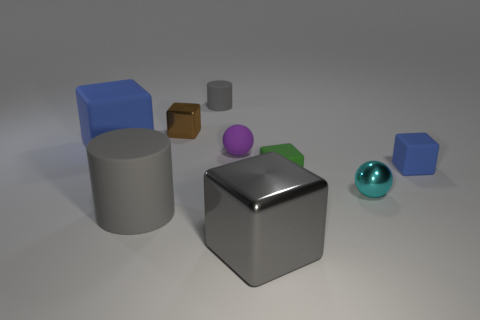Subtract all gray cylinders. How many were subtracted if there are1gray cylinders left? 1 Subtract all big metallic blocks. How many blocks are left? 4 Subtract all red balls. How many blue blocks are left? 2 Subtract all brown cubes. How many cubes are left? 4 Subtract 2 blocks. How many blocks are left? 3 Subtract all red blocks. Subtract all brown cylinders. How many blocks are left? 5 Subtract all big gray things. Subtract all matte cylinders. How many objects are left? 5 Add 5 brown objects. How many brown objects are left? 6 Add 6 brown cubes. How many brown cubes exist? 7 Subtract 0 yellow cylinders. How many objects are left? 9 